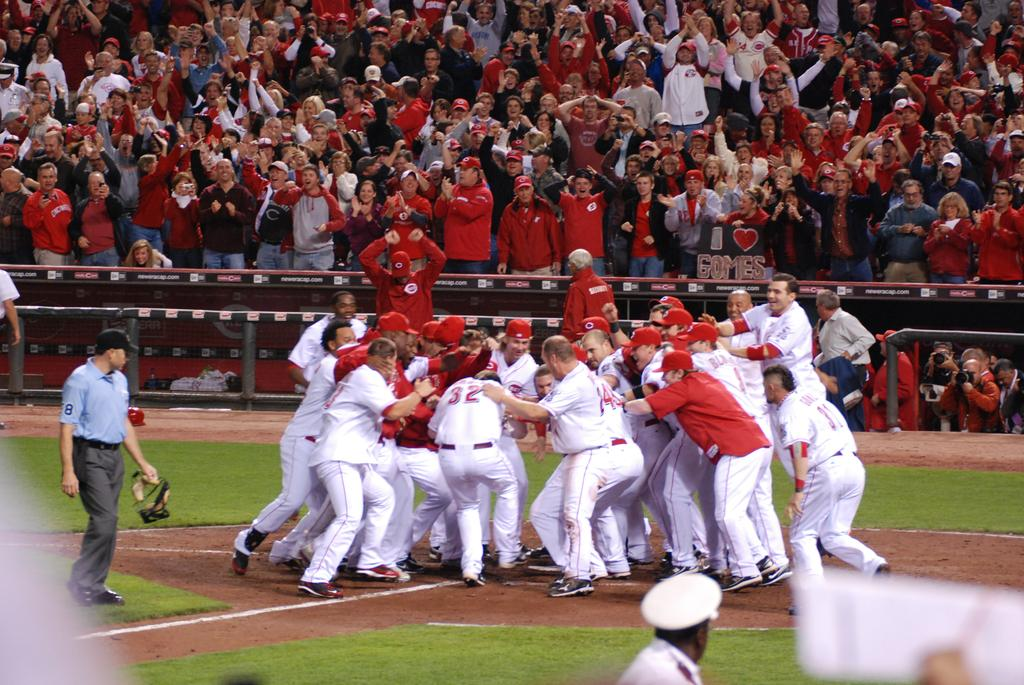<image>
Provide a brief description of the given image. Player number 32 with the white uniform has his right foot off the ground. 